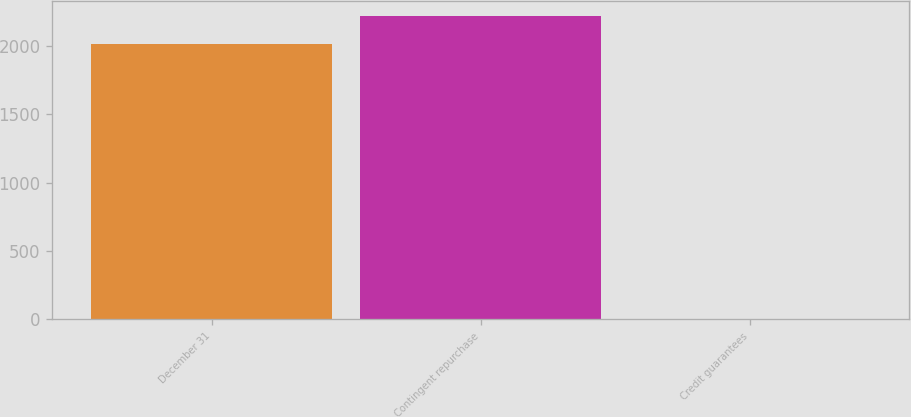Convert chart. <chart><loc_0><loc_0><loc_500><loc_500><bar_chart><fcel>December 31<fcel>Contingent repurchase<fcel>Credit guarantees<nl><fcel>2012<fcel>2218.1<fcel>4<nl></chart> 